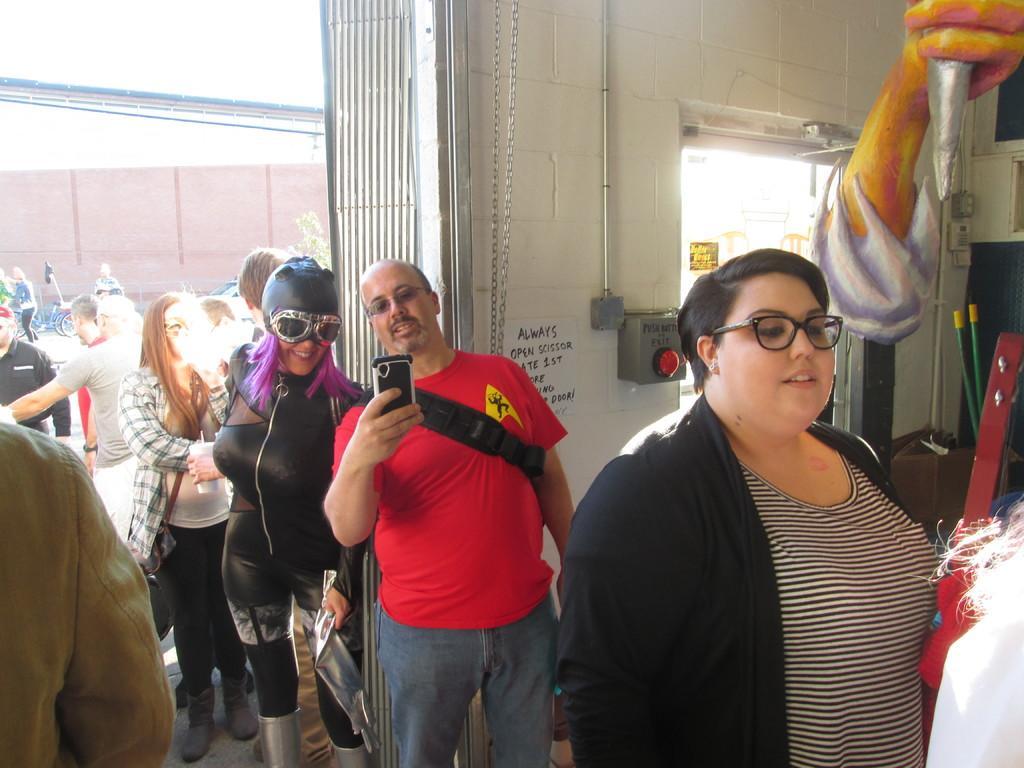In one or two sentences, can you explain what this image depicts? This image consists of a woman wearing black jacket. In the middle, there is a man holding a mobile. There are many people in this image. In the background, there is a wall. At the bottom, there is a floor. 